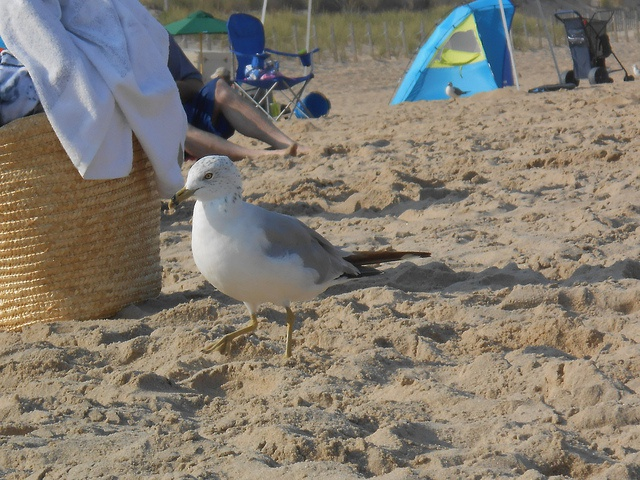Describe the objects in this image and their specific colors. I can see bird in lightgray, gray, and darkgray tones, people in lightgray, black, gray, and navy tones, chair in lightgray, navy, gray, and darkgray tones, umbrella in lightgray, teal, gray, and darkgreen tones, and bird in lightgray, gray, and darkgray tones in this image. 